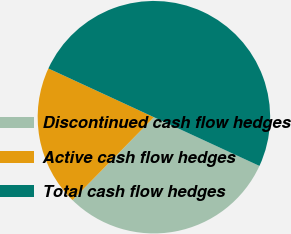Convert chart. <chart><loc_0><loc_0><loc_500><loc_500><pie_chart><fcel>Discontinued cash flow hedges<fcel>Active cash flow hedges<fcel>Total cash flow hedges<nl><fcel>30.47%<fcel>19.53%<fcel>50.0%<nl></chart> 